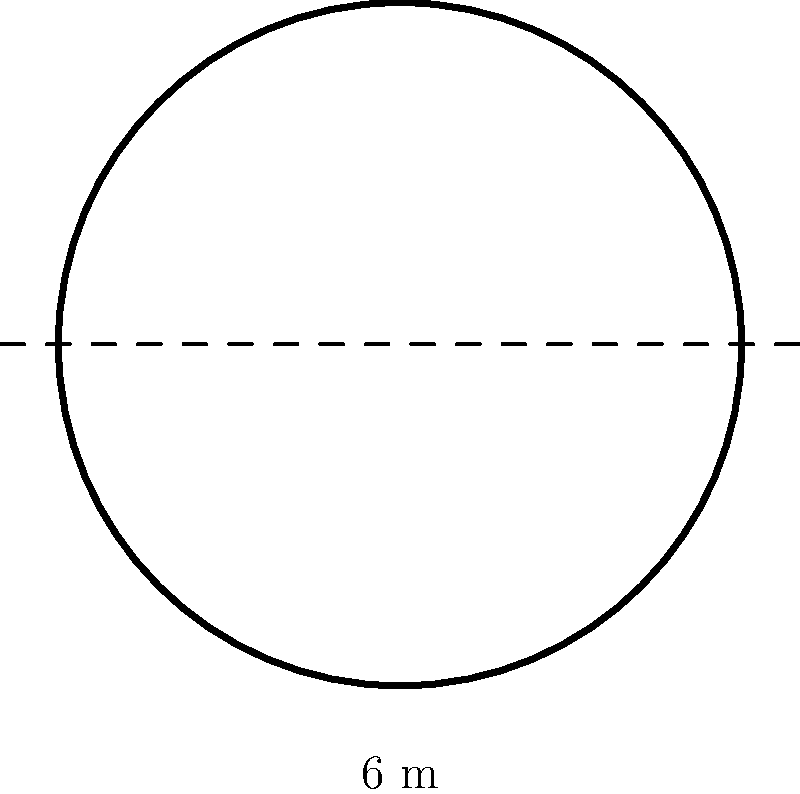As a local historian studying the Notre-Dame de Reims cathedral, you encounter a magnificent rose window. The circular window has a diameter of 6 meters. Estimate the area of this rose window, rounding your answer to the nearest square meter. (Use $\pi \approx 3.14$) To estimate the area of the circular rose window, we'll follow these steps:

1) The formula for the area of a circle is:
   $$A = \pi r^2$$
   where $A$ is the area and $r$ is the radius.

2) We're given the diameter, which is 6 meters. The radius is half of the diameter:
   $$r = \frac{6}{2} = 3\text{ meters}$$

3) Now, let's substitute this into our formula, using $\pi \approx 3.14$:
   $$A = 3.14 \times 3^2$$

4) Simplify:
   $$A = 3.14 \times 9 = 28.26\text{ square meters}$$

5) Rounding to the nearest square meter:
   $$A \approx 28\text{ square meters}$$

Thus, the estimated area of the rose window is approximately 28 square meters.
Answer: 28 square meters 